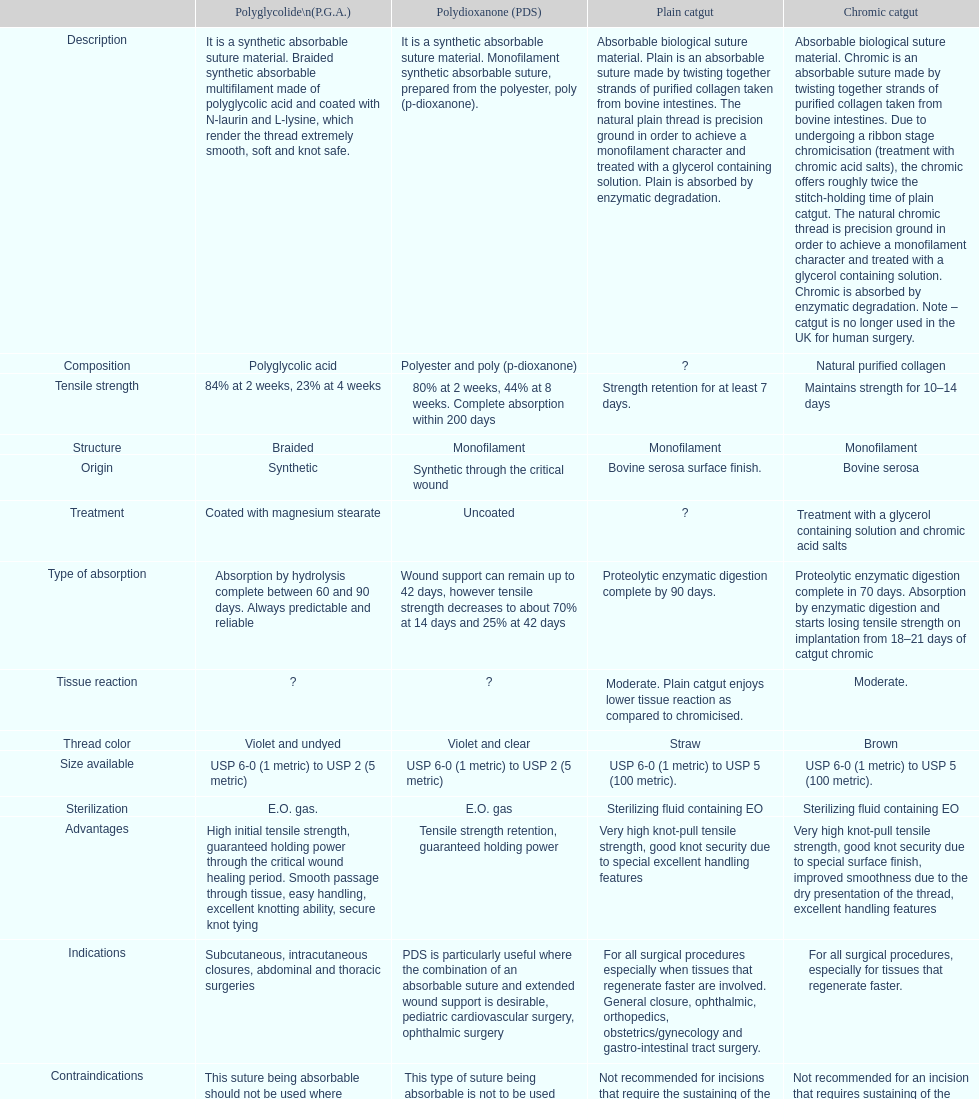How long does a chromic catgut maintain it's strength for 10-14 days. 